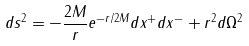<formula> <loc_0><loc_0><loc_500><loc_500>d s ^ { 2 } = - \frac { 2 M } { r } e ^ { - r / 2 M } d x ^ { + } d x ^ { - } + r ^ { 2 } d \Omega ^ { 2 }</formula> 